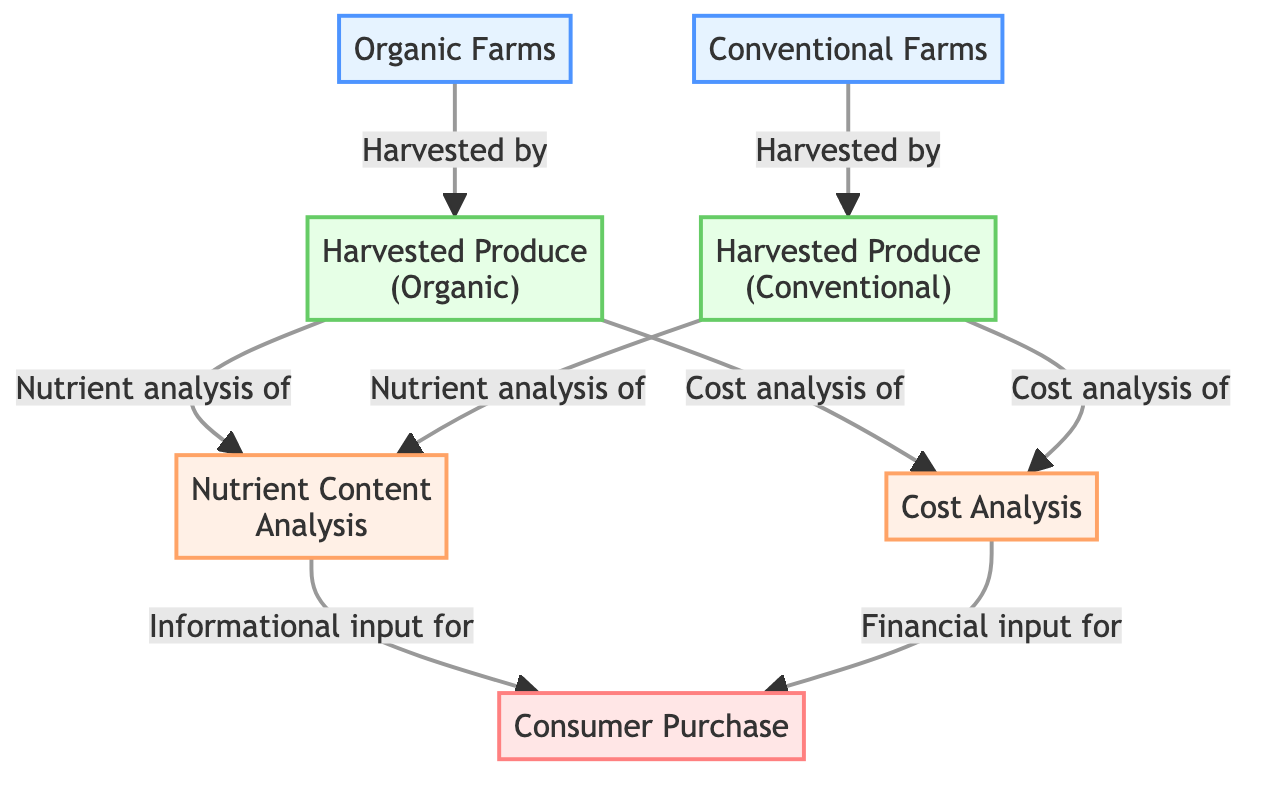What are the two types of farms shown in the diagram? The diagram shows two types of farms: "Organic Farms" and "Conventional Farms". This information is found in the first two nodes of the diagram.
Answer: Organic Farms, Conventional Farms How many types of harvested produce are analyzed in the diagram? The diagram includes two types of harvested produce: "Harvested Produce (Organic)" and "Harvested Produce (Conventional)". This can be counted from the nodes representing the harvested produce.
Answer: 2 What is the purpose of the "Nutrient Content Analysis" node? The "Nutrient Content Analysis" node is connected to both types of harvested produce, indicating that both organic and conventional produce undergo nutrient analysis. This shows that the purpose is to analyze the nutrient content of both types of produce.
Answer: Nutrient analysis Which node informs the consumer purchase regarding nutrient information? The arrow leading from the "Nutrient Content Analysis" node to the "Consumer Purchase" node indicates that the "Nutrient Content Analysis" provides informational input for consumer purchasing decisions.
Answer: Nutrient Content Analysis What is the relationship between "Harvested Produce (Organic)" and "Cost Analysis"? The arrow connects "Harvested Produce (Organic)" to "Cost Analysis", indicating that cost analysis is conducted for organic produce alongside nutrient analysis. This relationship highlights that both nutrient and cost analyses are linked to the organic produce.
Answer: Cost analysis Which type of produce contributes to both nutrient and cost analysis? Both "Harvested Produce (Organic)" and "Harvested Produce (Conventional)" contribute to nutrient and cost analysis, as indicated by the arrows leading to these respective analysis nodes from both types of harvested produce.
Answer: Both types Which node receives its input from the "Cost Analysis"? The "Consumer Purchase" node receives input from the "Cost Analysis" node, as shown by the directed arrow pointing towards the consumer purchase. This indicates that cost analysis influences consumer purchasing decisions.
Answer: Consumer Purchase How many nodes are in total in the diagram? By counting all the individual nodes represented in the diagram, we find that there are a total of seven nodes, which are "Organic Farms", "Conventional Farms", "Harvested Produce (Organic)", "Harvested Produce (Conventional)", "Nutrient Content Analysis", "Cost Analysis", and "Consumer Purchase".
Answer: 7 What type of analysis do both organic and conventional produce undergo? Both types of produce undergo "Nutrient Content Analysis", as indicated by the arrows leading from both harvested produce nodes to the nutrient analysis node, showing that analysis is vital regardless of the type.
Answer: Nutrient Content Analysis 